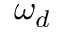Convert formula to latex. <formula><loc_0><loc_0><loc_500><loc_500>\omega _ { d }</formula> 